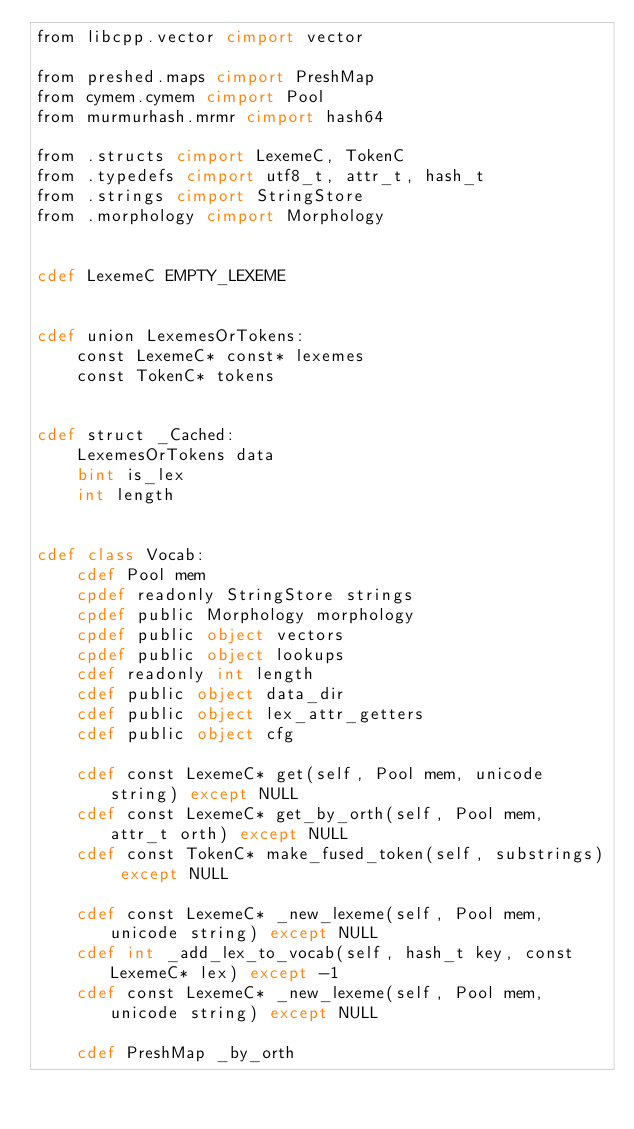<code> <loc_0><loc_0><loc_500><loc_500><_Cython_>from libcpp.vector cimport vector

from preshed.maps cimport PreshMap
from cymem.cymem cimport Pool
from murmurhash.mrmr cimport hash64

from .structs cimport LexemeC, TokenC
from .typedefs cimport utf8_t, attr_t, hash_t
from .strings cimport StringStore
from .morphology cimport Morphology


cdef LexemeC EMPTY_LEXEME


cdef union LexemesOrTokens:
    const LexemeC* const* lexemes
    const TokenC* tokens


cdef struct _Cached:
    LexemesOrTokens data
    bint is_lex
    int length


cdef class Vocab:
    cdef Pool mem
    cpdef readonly StringStore strings
    cpdef public Morphology morphology
    cpdef public object vectors
    cpdef public object lookups
    cdef readonly int length
    cdef public object data_dir
    cdef public object lex_attr_getters
    cdef public object cfg

    cdef const LexemeC* get(self, Pool mem, unicode string) except NULL
    cdef const LexemeC* get_by_orth(self, Pool mem, attr_t orth) except NULL
    cdef const TokenC* make_fused_token(self, substrings) except NULL

    cdef const LexemeC* _new_lexeme(self, Pool mem, unicode string) except NULL
    cdef int _add_lex_to_vocab(self, hash_t key, const LexemeC* lex) except -1
    cdef const LexemeC* _new_lexeme(self, Pool mem, unicode string) except NULL

    cdef PreshMap _by_orth
</code> 